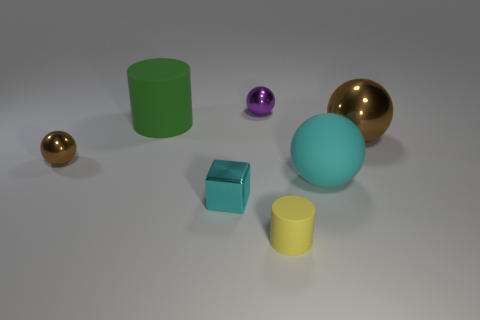Add 3 yellow matte objects. How many objects exist? 10 Subtract all cubes. How many objects are left? 6 Subtract all big purple matte cylinders. Subtract all rubber objects. How many objects are left? 4 Add 6 tiny brown shiny spheres. How many tiny brown shiny spheres are left? 7 Add 5 big brown things. How many big brown things exist? 6 Subtract 0 purple cylinders. How many objects are left? 7 